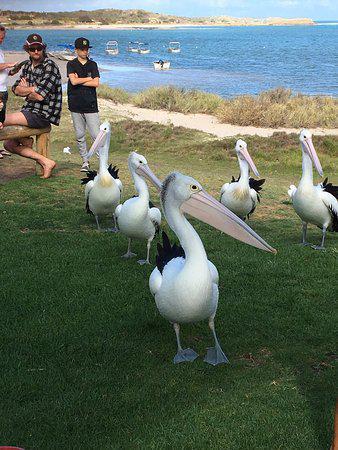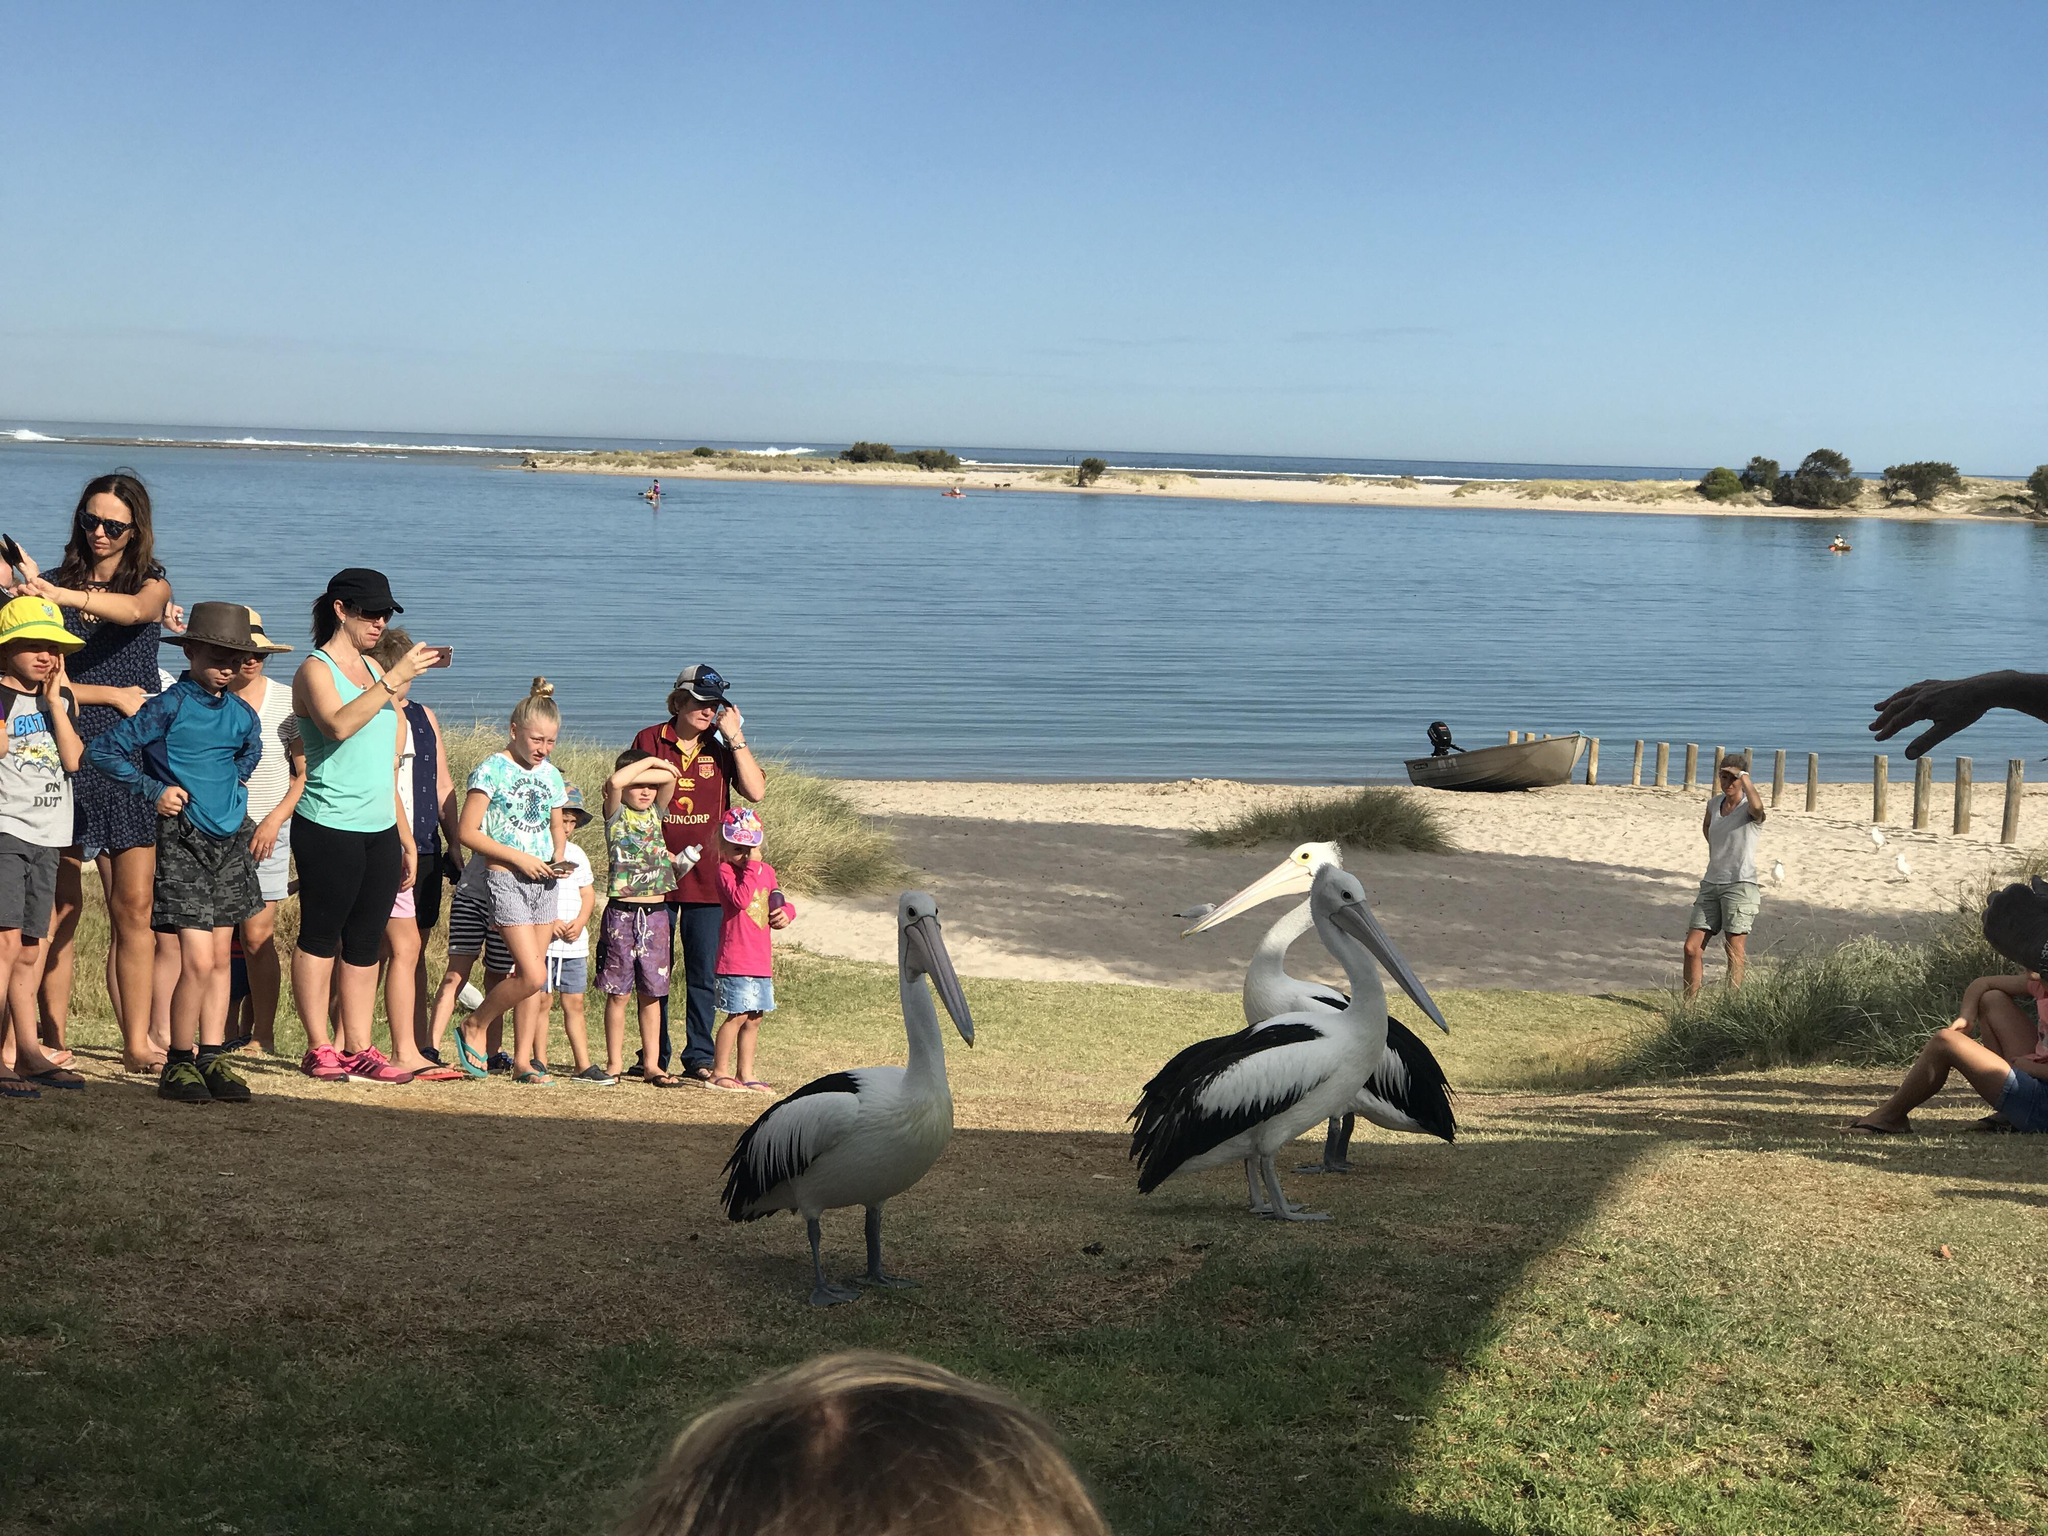The first image is the image on the left, the second image is the image on the right. Evaluate the accuracy of this statement regarding the images: "There is at least three pelicans standing outside.". Is it true? Answer yes or no. Yes. The first image is the image on the left, the second image is the image on the right. Examine the images to the left and right. Is the description "In the image on the right, you can see exactly three of the birds, as there are none in the background." accurate? Answer yes or no. Yes. 